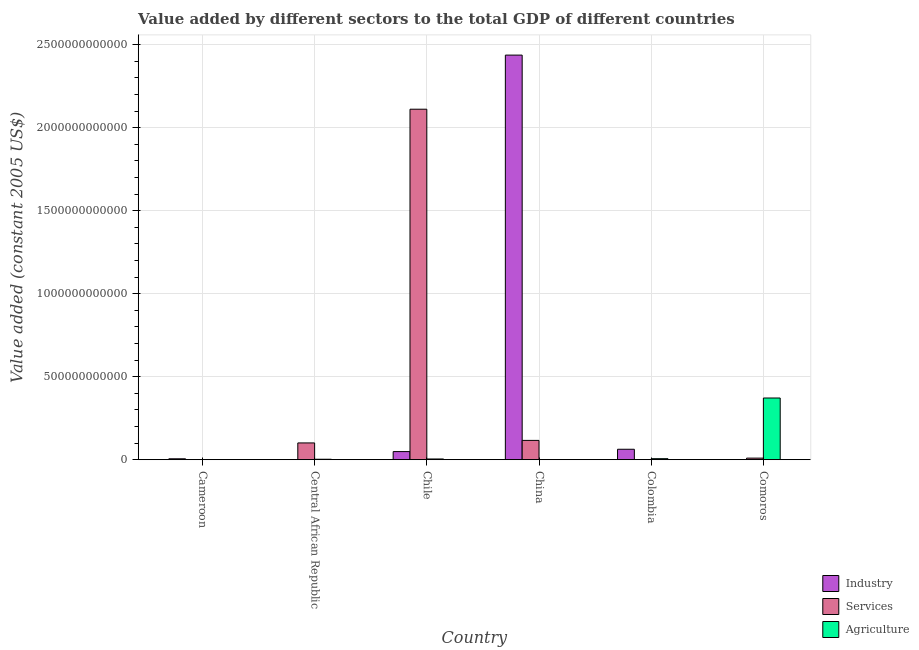How many different coloured bars are there?
Keep it short and to the point. 3. How many groups of bars are there?
Keep it short and to the point. 6. Are the number of bars per tick equal to the number of legend labels?
Make the answer very short. Yes. How many bars are there on the 1st tick from the left?
Your answer should be very brief. 3. What is the label of the 1st group of bars from the left?
Provide a succinct answer. Cameroon. In how many cases, is the number of bars for a given country not equal to the number of legend labels?
Make the answer very short. 0. What is the value added by agricultural sector in China?
Provide a succinct answer. 5.85e+08. Across all countries, what is the maximum value added by agricultural sector?
Offer a terse response. 3.72e+11. Across all countries, what is the minimum value added by agricultural sector?
Your answer should be very brief. 1.40e+08. In which country was the value added by services maximum?
Offer a terse response. Chile. In which country was the value added by agricultural sector minimum?
Ensure brevity in your answer.  Cameroon. What is the total value added by industrial sector in the graph?
Make the answer very short. 2.55e+12. What is the difference between the value added by services in China and that in Comoros?
Make the answer very short. 1.07e+11. What is the difference between the value added by services in Comoros and the value added by industrial sector in Colombia?
Keep it short and to the point. -5.34e+1. What is the average value added by industrial sector per country?
Provide a short and direct response. 4.26e+11. What is the difference between the value added by agricultural sector and value added by industrial sector in Cameroon?
Your answer should be compact. -5.36e+09. What is the ratio of the value added by agricultural sector in China to that in Colombia?
Your response must be concise. 0.1. What is the difference between the highest and the second highest value added by services?
Ensure brevity in your answer.  2.00e+12. What is the difference between the highest and the lowest value added by industrial sector?
Keep it short and to the point. 2.44e+12. What does the 1st bar from the left in Chile represents?
Make the answer very short. Industry. What does the 3rd bar from the right in Central African Republic represents?
Keep it short and to the point. Industry. Is it the case that in every country, the sum of the value added by industrial sector and value added by services is greater than the value added by agricultural sector?
Your answer should be very brief. No. Are all the bars in the graph horizontal?
Keep it short and to the point. No. What is the difference between two consecutive major ticks on the Y-axis?
Give a very brief answer. 5.00e+11. Does the graph contain any zero values?
Your response must be concise. No. Does the graph contain grids?
Offer a very short reply. Yes. Where does the legend appear in the graph?
Make the answer very short. Bottom right. How many legend labels are there?
Make the answer very short. 3. How are the legend labels stacked?
Provide a short and direct response. Vertical. What is the title of the graph?
Provide a succinct answer. Value added by different sectors to the total GDP of different countries. Does "Ages 0-14" appear as one of the legend labels in the graph?
Keep it short and to the point. No. What is the label or title of the X-axis?
Provide a succinct answer. Country. What is the label or title of the Y-axis?
Ensure brevity in your answer.  Value added (constant 2005 US$). What is the Value added (constant 2005 US$) in Industry in Cameroon?
Make the answer very short. 5.50e+09. What is the Value added (constant 2005 US$) in Services in Cameroon?
Offer a very short reply. 2.96e+08. What is the Value added (constant 2005 US$) of Agriculture in Cameroon?
Your response must be concise. 1.40e+08. What is the Value added (constant 2005 US$) in Industry in Central African Republic?
Make the answer very short. 1.26e+08. What is the Value added (constant 2005 US$) of Services in Central African Republic?
Provide a short and direct response. 1.01e+11. What is the Value added (constant 2005 US$) in Agriculture in Central African Republic?
Offer a terse response. 2.71e+09. What is the Value added (constant 2005 US$) in Industry in Chile?
Provide a succinct answer. 4.89e+1. What is the Value added (constant 2005 US$) of Services in Chile?
Provide a short and direct response. 2.11e+12. What is the Value added (constant 2005 US$) of Agriculture in Chile?
Ensure brevity in your answer.  4.34e+09. What is the Value added (constant 2005 US$) of Industry in China?
Keep it short and to the point. 2.44e+12. What is the Value added (constant 2005 US$) in Services in China?
Offer a very short reply. 1.16e+11. What is the Value added (constant 2005 US$) of Agriculture in China?
Provide a short and direct response. 5.85e+08. What is the Value added (constant 2005 US$) in Industry in Colombia?
Make the answer very short. 6.29e+1. What is the Value added (constant 2005 US$) of Services in Colombia?
Your answer should be compact. 1.96e+08. What is the Value added (constant 2005 US$) of Agriculture in Colombia?
Offer a terse response. 6.13e+09. What is the Value added (constant 2005 US$) in Industry in Comoros?
Ensure brevity in your answer.  5.82e+07. What is the Value added (constant 2005 US$) in Services in Comoros?
Keep it short and to the point. 9.50e+09. What is the Value added (constant 2005 US$) in Agriculture in Comoros?
Keep it short and to the point. 3.72e+11. Across all countries, what is the maximum Value added (constant 2005 US$) in Industry?
Ensure brevity in your answer.  2.44e+12. Across all countries, what is the maximum Value added (constant 2005 US$) of Services?
Provide a short and direct response. 2.11e+12. Across all countries, what is the maximum Value added (constant 2005 US$) of Agriculture?
Provide a succinct answer. 3.72e+11. Across all countries, what is the minimum Value added (constant 2005 US$) in Industry?
Provide a short and direct response. 5.82e+07. Across all countries, what is the minimum Value added (constant 2005 US$) of Services?
Make the answer very short. 1.96e+08. Across all countries, what is the minimum Value added (constant 2005 US$) of Agriculture?
Your response must be concise. 1.40e+08. What is the total Value added (constant 2005 US$) of Industry in the graph?
Provide a succinct answer. 2.55e+12. What is the total Value added (constant 2005 US$) in Services in the graph?
Provide a short and direct response. 2.34e+12. What is the total Value added (constant 2005 US$) of Agriculture in the graph?
Make the answer very short. 3.86e+11. What is the difference between the Value added (constant 2005 US$) of Industry in Cameroon and that in Central African Republic?
Keep it short and to the point. 5.38e+09. What is the difference between the Value added (constant 2005 US$) in Services in Cameroon and that in Central African Republic?
Make the answer very short. -1.01e+11. What is the difference between the Value added (constant 2005 US$) in Agriculture in Cameroon and that in Central African Republic?
Your answer should be very brief. -2.57e+09. What is the difference between the Value added (constant 2005 US$) of Industry in Cameroon and that in Chile?
Offer a terse response. -4.34e+1. What is the difference between the Value added (constant 2005 US$) of Services in Cameroon and that in Chile?
Offer a very short reply. -2.11e+12. What is the difference between the Value added (constant 2005 US$) in Agriculture in Cameroon and that in Chile?
Offer a terse response. -4.20e+09. What is the difference between the Value added (constant 2005 US$) in Industry in Cameroon and that in China?
Make the answer very short. -2.43e+12. What is the difference between the Value added (constant 2005 US$) of Services in Cameroon and that in China?
Your response must be concise. -1.16e+11. What is the difference between the Value added (constant 2005 US$) in Agriculture in Cameroon and that in China?
Give a very brief answer. -4.45e+08. What is the difference between the Value added (constant 2005 US$) of Industry in Cameroon and that in Colombia?
Offer a terse response. -5.74e+1. What is the difference between the Value added (constant 2005 US$) of Services in Cameroon and that in Colombia?
Offer a terse response. 9.98e+07. What is the difference between the Value added (constant 2005 US$) of Agriculture in Cameroon and that in Colombia?
Offer a very short reply. -5.99e+09. What is the difference between the Value added (constant 2005 US$) in Industry in Cameroon and that in Comoros?
Ensure brevity in your answer.  5.44e+09. What is the difference between the Value added (constant 2005 US$) of Services in Cameroon and that in Comoros?
Give a very brief answer. -9.20e+09. What is the difference between the Value added (constant 2005 US$) of Agriculture in Cameroon and that in Comoros?
Offer a terse response. -3.72e+11. What is the difference between the Value added (constant 2005 US$) in Industry in Central African Republic and that in Chile?
Offer a very short reply. -4.87e+1. What is the difference between the Value added (constant 2005 US$) in Services in Central African Republic and that in Chile?
Provide a succinct answer. -2.01e+12. What is the difference between the Value added (constant 2005 US$) of Agriculture in Central African Republic and that in Chile?
Your answer should be very brief. -1.63e+09. What is the difference between the Value added (constant 2005 US$) in Industry in Central African Republic and that in China?
Provide a short and direct response. -2.44e+12. What is the difference between the Value added (constant 2005 US$) of Services in Central African Republic and that in China?
Give a very brief answer. -1.52e+1. What is the difference between the Value added (constant 2005 US$) of Agriculture in Central African Republic and that in China?
Offer a terse response. 2.12e+09. What is the difference between the Value added (constant 2005 US$) of Industry in Central African Republic and that in Colombia?
Make the answer very short. -6.27e+1. What is the difference between the Value added (constant 2005 US$) of Services in Central African Republic and that in Colombia?
Your response must be concise. 1.01e+11. What is the difference between the Value added (constant 2005 US$) of Agriculture in Central African Republic and that in Colombia?
Your answer should be compact. -3.42e+09. What is the difference between the Value added (constant 2005 US$) in Industry in Central African Republic and that in Comoros?
Offer a terse response. 6.74e+07. What is the difference between the Value added (constant 2005 US$) of Services in Central African Republic and that in Comoros?
Keep it short and to the point. 9.16e+1. What is the difference between the Value added (constant 2005 US$) of Agriculture in Central African Republic and that in Comoros?
Offer a terse response. -3.69e+11. What is the difference between the Value added (constant 2005 US$) in Industry in Chile and that in China?
Ensure brevity in your answer.  -2.39e+12. What is the difference between the Value added (constant 2005 US$) of Services in Chile and that in China?
Your answer should be compact. 2.00e+12. What is the difference between the Value added (constant 2005 US$) in Agriculture in Chile and that in China?
Your answer should be very brief. 3.75e+09. What is the difference between the Value added (constant 2005 US$) of Industry in Chile and that in Colombia?
Make the answer very short. -1.40e+1. What is the difference between the Value added (constant 2005 US$) of Services in Chile and that in Colombia?
Your answer should be very brief. 2.11e+12. What is the difference between the Value added (constant 2005 US$) of Agriculture in Chile and that in Colombia?
Ensure brevity in your answer.  -1.79e+09. What is the difference between the Value added (constant 2005 US$) in Industry in Chile and that in Comoros?
Provide a succinct answer. 4.88e+1. What is the difference between the Value added (constant 2005 US$) in Services in Chile and that in Comoros?
Your response must be concise. 2.10e+12. What is the difference between the Value added (constant 2005 US$) in Agriculture in Chile and that in Comoros?
Your response must be concise. -3.67e+11. What is the difference between the Value added (constant 2005 US$) of Industry in China and that in Colombia?
Give a very brief answer. 2.37e+12. What is the difference between the Value added (constant 2005 US$) in Services in China and that in Colombia?
Your answer should be very brief. 1.16e+11. What is the difference between the Value added (constant 2005 US$) in Agriculture in China and that in Colombia?
Keep it short and to the point. -5.54e+09. What is the difference between the Value added (constant 2005 US$) of Industry in China and that in Comoros?
Your response must be concise. 2.44e+12. What is the difference between the Value added (constant 2005 US$) of Services in China and that in Comoros?
Provide a succinct answer. 1.07e+11. What is the difference between the Value added (constant 2005 US$) of Agriculture in China and that in Comoros?
Ensure brevity in your answer.  -3.71e+11. What is the difference between the Value added (constant 2005 US$) of Industry in Colombia and that in Comoros?
Give a very brief answer. 6.28e+1. What is the difference between the Value added (constant 2005 US$) of Services in Colombia and that in Comoros?
Your answer should be compact. -9.30e+09. What is the difference between the Value added (constant 2005 US$) in Agriculture in Colombia and that in Comoros?
Give a very brief answer. -3.66e+11. What is the difference between the Value added (constant 2005 US$) of Industry in Cameroon and the Value added (constant 2005 US$) of Services in Central African Republic?
Provide a short and direct response. -9.56e+1. What is the difference between the Value added (constant 2005 US$) in Industry in Cameroon and the Value added (constant 2005 US$) in Agriculture in Central African Republic?
Offer a very short reply. 2.79e+09. What is the difference between the Value added (constant 2005 US$) of Services in Cameroon and the Value added (constant 2005 US$) of Agriculture in Central African Republic?
Provide a succinct answer. -2.41e+09. What is the difference between the Value added (constant 2005 US$) of Industry in Cameroon and the Value added (constant 2005 US$) of Services in Chile?
Give a very brief answer. -2.11e+12. What is the difference between the Value added (constant 2005 US$) in Industry in Cameroon and the Value added (constant 2005 US$) in Agriculture in Chile?
Give a very brief answer. 1.16e+09. What is the difference between the Value added (constant 2005 US$) in Services in Cameroon and the Value added (constant 2005 US$) in Agriculture in Chile?
Provide a short and direct response. -4.04e+09. What is the difference between the Value added (constant 2005 US$) of Industry in Cameroon and the Value added (constant 2005 US$) of Services in China?
Keep it short and to the point. -1.11e+11. What is the difference between the Value added (constant 2005 US$) of Industry in Cameroon and the Value added (constant 2005 US$) of Agriculture in China?
Make the answer very short. 4.92e+09. What is the difference between the Value added (constant 2005 US$) of Services in Cameroon and the Value added (constant 2005 US$) of Agriculture in China?
Ensure brevity in your answer.  -2.89e+08. What is the difference between the Value added (constant 2005 US$) of Industry in Cameroon and the Value added (constant 2005 US$) of Services in Colombia?
Give a very brief answer. 5.30e+09. What is the difference between the Value added (constant 2005 US$) of Industry in Cameroon and the Value added (constant 2005 US$) of Agriculture in Colombia?
Provide a succinct answer. -6.28e+08. What is the difference between the Value added (constant 2005 US$) in Services in Cameroon and the Value added (constant 2005 US$) in Agriculture in Colombia?
Give a very brief answer. -5.83e+09. What is the difference between the Value added (constant 2005 US$) of Industry in Cameroon and the Value added (constant 2005 US$) of Services in Comoros?
Offer a very short reply. -4.00e+09. What is the difference between the Value added (constant 2005 US$) of Industry in Cameroon and the Value added (constant 2005 US$) of Agriculture in Comoros?
Offer a very short reply. -3.66e+11. What is the difference between the Value added (constant 2005 US$) in Services in Cameroon and the Value added (constant 2005 US$) in Agriculture in Comoros?
Make the answer very short. -3.71e+11. What is the difference between the Value added (constant 2005 US$) of Industry in Central African Republic and the Value added (constant 2005 US$) of Services in Chile?
Offer a terse response. -2.11e+12. What is the difference between the Value added (constant 2005 US$) in Industry in Central African Republic and the Value added (constant 2005 US$) in Agriculture in Chile?
Your answer should be compact. -4.21e+09. What is the difference between the Value added (constant 2005 US$) in Services in Central African Republic and the Value added (constant 2005 US$) in Agriculture in Chile?
Your answer should be very brief. 9.67e+1. What is the difference between the Value added (constant 2005 US$) in Industry in Central African Republic and the Value added (constant 2005 US$) in Services in China?
Provide a short and direct response. -1.16e+11. What is the difference between the Value added (constant 2005 US$) of Industry in Central African Republic and the Value added (constant 2005 US$) of Agriculture in China?
Provide a succinct answer. -4.59e+08. What is the difference between the Value added (constant 2005 US$) in Services in Central African Republic and the Value added (constant 2005 US$) in Agriculture in China?
Your response must be concise. 1.00e+11. What is the difference between the Value added (constant 2005 US$) in Industry in Central African Republic and the Value added (constant 2005 US$) in Services in Colombia?
Offer a very short reply. -7.02e+07. What is the difference between the Value added (constant 2005 US$) in Industry in Central African Republic and the Value added (constant 2005 US$) in Agriculture in Colombia?
Give a very brief answer. -6.00e+09. What is the difference between the Value added (constant 2005 US$) in Services in Central African Republic and the Value added (constant 2005 US$) in Agriculture in Colombia?
Your response must be concise. 9.49e+1. What is the difference between the Value added (constant 2005 US$) of Industry in Central African Republic and the Value added (constant 2005 US$) of Services in Comoros?
Your answer should be very brief. -9.37e+09. What is the difference between the Value added (constant 2005 US$) of Industry in Central African Republic and the Value added (constant 2005 US$) of Agriculture in Comoros?
Provide a succinct answer. -3.72e+11. What is the difference between the Value added (constant 2005 US$) of Services in Central African Republic and the Value added (constant 2005 US$) of Agriculture in Comoros?
Your response must be concise. -2.71e+11. What is the difference between the Value added (constant 2005 US$) in Industry in Chile and the Value added (constant 2005 US$) in Services in China?
Keep it short and to the point. -6.74e+1. What is the difference between the Value added (constant 2005 US$) of Industry in Chile and the Value added (constant 2005 US$) of Agriculture in China?
Offer a very short reply. 4.83e+1. What is the difference between the Value added (constant 2005 US$) of Services in Chile and the Value added (constant 2005 US$) of Agriculture in China?
Offer a terse response. 2.11e+12. What is the difference between the Value added (constant 2005 US$) in Industry in Chile and the Value added (constant 2005 US$) in Services in Colombia?
Your answer should be very brief. 4.87e+1. What is the difference between the Value added (constant 2005 US$) in Industry in Chile and the Value added (constant 2005 US$) in Agriculture in Colombia?
Give a very brief answer. 4.27e+1. What is the difference between the Value added (constant 2005 US$) of Services in Chile and the Value added (constant 2005 US$) of Agriculture in Colombia?
Provide a short and direct response. 2.11e+12. What is the difference between the Value added (constant 2005 US$) of Industry in Chile and the Value added (constant 2005 US$) of Services in Comoros?
Provide a succinct answer. 3.94e+1. What is the difference between the Value added (constant 2005 US$) in Industry in Chile and the Value added (constant 2005 US$) in Agriculture in Comoros?
Offer a very short reply. -3.23e+11. What is the difference between the Value added (constant 2005 US$) of Services in Chile and the Value added (constant 2005 US$) of Agriculture in Comoros?
Give a very brief answer. 1.74e+12. What is the difference between the Value added (constant 2005 US$) of Industry in China and the Value added (constant 2005 US$) of Services in Colombia?
Keep it short and to the point. 2.44e+12. What is the difference between the Value added (constant 2005 US$) in Industry in China and the Value added (constant 2005 US$) in Agriculture in Colombia?
Give a very brief answer. 2.43e+12. What is the difference between the Value added (constant 2005 US$) of Services in China and the Value added (constant 2005 US$) of Agriculture in Colombia?
Ensure brevity in your answer.  1.10e+11. What is the difference between the Value added (constant 2005 US$) of Industry in China and the Value added (constant 2005 US$) of Services in Comoros?
Keep it short and to the point. 2.43e+12. What is the difference between the Value added (constant 2005 US$) of Industry in China and the Value added (constant 2005 US$) of Agriculture in Comoros?
Offer a terse response. 2.07e+12. What is the difference between the Value added (constant 2005 US$) in Services in China and the Value added (constant 2005 US$) in Agriculture in Comoros?
Make the answer very short. -2.55e+11. What is the difference between the Value added (constant 2005 US$) in Industry in Colombia and the Value added (constant 2005 US$) in Services in Comoros?
Provide a short and direct response. 5.34e+1. What is the difference between the Value added (constant 2005 US$) in Industry in Colombia and the Value added (constant 2005 US$) in Agriculture in Comoros?
Give a very brief answer. -3.09e+11. What is the difference between the Value added (constant 2005 US$) in Services in Colombia and the Value added (constant 2005 US$) in Agriculture in Comoros?
Make the answer very short. -3.71e+11. What is the average Value added (constant 2005 US$) in Industry per country?
Provide a short and direct response. 4.26e+11. What is the average Value added (constant 2005 US$) of Services per country?
Your response must be concise. 3.90e+11. What is the average Value added (constant 2005 US$) of Agriculture per country?
Provide a short and direct response. 6.43e+1. What is the difference between the Value added (constant 2005 US$) in Industry and Value added (constant 2005 US$) in Services in Cameroon?
Your answer should be very brief. 5.21e+09. What is the difference between the Value added (constant 2005 US$) in Industry and Value added (constant 2005 US$) in Agriculture in Cameroon?
Provide a succinct answer. 5.36e+09. What is the difference between the Value added (constant 2005 US$) in Services and Value added (constant 2005 US$) in Agriculture in Cameroon?
Your answer should be compact. 1.55e+08. What is the difference between the Value added (constant 2005 US$) of Industry and Value added (constant 2005 US$) of Services in Central African Republic?
Make the answer very short. -1.01e+11. What is the difference between the Value added (constant 2005 US$) of Industry and Value added (constant 2005 US$) of Agriculture in Central African Republic?
Ensure brevity in your answer.  -2.58e+09. What is the difference between the Value added (constant 2005 US$) of Services and Value added (constant 2005 US$) of Agriculture in Central African Republic?
Ensure brevity in your answer.  9.84e+1. What is the difference between the Value added (constant 2005 US$) of Industry and Value added (constant 2005 US$) of Services in Chile?
Offer a very short reply. -2.06e+12. What is the difference between the Value added (constant 2005 US$) of Industry and Value added (constant 2005 US$) of Agriculture in Chile?
Offer a very short reply. 4.45e+1. What is the difference between the Value added (constant 2005 US$) in Services and Value added (constant 2005 US$) in Agriculture in Chile?
Offer a terse response. 2.11e+12. What is the difference between the Value added (constant 2005 US$) in Industry and Value added (constant 2005 US$) in Services in China?
Give a very brief answer. 2.32e+12. What is the difference between the Value added (constant 2005 US$) in Industry and Value added (constant 2005 US$) in Agriculture in China?
Provide a succinct answer. 2.44e+12. What is the difference between the Value added (constant 2005 US$) of Services and Value added (constant 2005 US$) of Agriculture in China?
Give a very brief answer. 1.16e+11. What is the difference between the Value added (constant 2005 US$) of Industry and Value added (constant 2005 US$) of Services in Colombia?
Make the answer very short. 6.27e+1. What is the difference between the Value added (constant 2005 US$) in Industry and Value added (constant 2005 US$) in Agriculture in Colombia?
Provide a succinct answer. 5.67e+1. What is the difference between the Value added (constant 2005 US$) in Services and Value added (constant 2005 US$) in Agriculture in Colombia?
Offer a very short reply. -5.93e+09. What is the difference between the Value added (constant 2005 US$) of Industry and Value added (constant 2005 US$) of Services in Comoros?
Provide a short and direct response. -9.44e+09. What is the difference between the Value added (constant 2005 US$) in Industry and Value added (constant 2005 US$) in Agriculture in Comoros?
Your response must be concise. -3.72e+11. What is the difference between the Value added (constant 2005 US$) in Services and Value added (constant 2005 US$) in Agriculture in Comoros?
Your answer should be compact. -3.62e+11. What is the ratio of the Value added (constant 2005 US$) of Industry in Cameroon to that in Central African Republic?
Your answer should be very brief. 43.79. What is the ratio of the Value added (constant 2005 US$) of Services in Cameroon to that in Central African Republic?
Your response must be concise. 0. What is the ratio of the Value added (constant 2005 US$) in Agriculture in Cameroon to that in Central African Republic?
Offer a very short reply. 0.05. What is the ratio of the Value added (constant 2005 US$) of Industry in Cameroon to that in Chile?
Your response must be concise. 0.11. What is the ratio of the Value added (constant 2005 US$) in Agriculture in Cameroon to that in Chile?
Give a very brief answer. 0.03. What is the ratio of the Value added (constant 2005 US$) of Industry in Cameroon to that in China?
Offer a very short reply. 0. What is the ratio of the Value added (constant 2005 US$) in Services in Cameroon to that in China?
Your answer should be very brief. 0. What is the ratio of the Value added (constant 2005 US$) of Agriculture in Cameroon to that in China?
Offer a terse response. 0.24. What is the ratio of the Value added (constant 2005 US$) in Industry in Cameroon to that in Colombia?
Your answer should be compact. 0.09. What is the ratio of the Value added (constant 2005 US$) in Services in Cameroon to that in Colombia?
Provide a succinct answer. 1.51. What is the ratio of the Value added (constant 2005 US$) in Agriculture in Cameroon to that in Colombia?
Your answer should be very brief. 0.02. What is the ratio of the Value added (constant 2005 US$) in Industry in Cameroon to that in Comoros?
Keep it short and to the point. 94.46. What is the ratio of the Value added (constant 2005 US$) of Services in Cameroon to that in Comoros?
Provide a short and direct response. 0.03. What is the ratio of the Value added (constant 2005 US$) of Industry in Central African Republic to that in Chile?
Provide a short and direct response. 0. What is the ratio of the Value added (constant 2005 US$) of Services in Central African Republic to that in Chile?
Provide a succinct answer. 0.05. What is the ratio of the Value added (constant 2005 US$) of Agriculture in Central African Republic to that in Chile?
Provide a short and direct response. 0.62. What is the ratio of the Value added (constant 2005 US$) in Services in Central African Republic to that in China?
Your answer should be very brief. 0.87. What is the ratio of the Value added (constant 2005 US$) in Agriculture in Central African Republic to that in China?
Give a very brief answer. 4.63. What is the ratio of the Value added (constant 2005 US$) in Industry in Central African Republic to that in Colombia?
Give a very brief answer. 0. What is the ratio of the Value added (constant 2005 US$) of Services in Central African Republic to that in Colombia?
Your response must be concise. 516.12. What is the ratio of the Value added (constant 2005 US$) of Agriculture in Central African Republic to that in Colombia?
Make the answer very short. 0.44. What is the ratio of the Value added (constant 2005 US$) in Industry in Central African Republic to that in Comoros?
Offer a very short reply. 2.16. What is the ratio of the Value added (constant 2005 US$) in Services in Central African Republic to that in Comoros?
Offer a very short reply. 10.64. What is the ratio of the Value added (constant 2005 US$) of Agriculture in Central African Republic to that in Comoros?
Give a very brief answer. 0.01. What is the ratio of the Value added (constant 2005 US$) of Industry in Chile to that in China?
Give a very brief answer. 0.02. What is the ratio of the Value added (constant 2005 US$) in Services in Chile to that in China?
Provide a succinct answer. 18.16. What is the ratio of the Value added (constant 2005 US$) in Agriculture in Chile to that in China?
Ensure brevity in your answer.  7.41. What is the ratio of the Value added (constant 2005 US$) of Industry in Chile to that in Colombia?
Your answer should be compact. 0.78. What is the ratio of the Value added (constant 2005 US$) in Services in Chile to that in Colombia?
Your answer should be compact. 1.08e+04. What is the ratio of the Value added (constant 2005 US$) of Agriculture in Chile to that in Colombia?
Your answer should be very brief. 0.71. What is the ratio of the Value added (constant 2005 US$) of Industry in Chile to that in Comoros?
Provide a short and direct response. 839.04. What is the ratio of the Value added (constant 2005 US$) in Services in Chile to that in Comoros?
Keep it short and to the point. 222.28. What is the ratio of the Value added (constant 2005 US$) of Agriculture in Chile to that in Comoros?
Your response must be concise. 0.01. What is the ratio of the Value added (constant 2005 US$) of Industry in China to that in Colombia?
Provide a short and direct response. 38.78. What is the ratio of the Value added (constant 2005 US$) in Services in China to that in Colombia?
Your answer should be very brief. 593.89. What is the ratio of the Value added (constant 2005 US$) in Agriculture in China to that in Colombia?
Ensure brevity in your answer.  0.1. What is the ratio of the Value added (constant 2005 US$) in Industry in China to that in Comoros?
Your answer should be compact. 4.19e+04. What is the ratio of the Value added (constant 2005 US$) of Services in China to that in Comoros?
Your response must be concise. 12.24. What is the ratio of the Value added (constant 2005 US$) of Agriculture in China to that in Comoros?
Keep it short and to the point. 0. What is the ratio of the Value added (constant 2005 US$) of Industry in Colombia to that in Comoros?
Provide a succinct answer. 1079.4. What is the ratio of the Value added (constant 2005 US$) of Services in Colombia to that in Comoros?
Provide a short and direct response. 0.02. What is the ratio of the Value added (constant 2005 US$) of Agriculture in Colombia to that in Comoros?
Keep it short and to the point. 0.02. What is the difference between the highest and the second highest Value added (constant 2005 US$) of Industry?
Give a very brief answer. 2.37e+12. What is the difference between the highest and the second highest Value added (constant 2005 US$) of Services?
Your response must be concise. 2.00e+12. What is the difference between the highest and the second highest Value added (constant 2005 US$) of Agriculture?
Offer a terse response. 3.66e+11. What is the difference between the highest and the lowest Value added (constant 2005 US$) of Industry?
Give a very brief answer. 2.44e+12. What is the difference between the highest and the lowest Value added (constant 2005 US$) in Services?
Ensure brevity in your answer.  2.11e+12. What is the difference between the highest and the lowest Value added (constant 2005 US$) in Agriculture?
Offer a very short reply. 3.72e+11. 